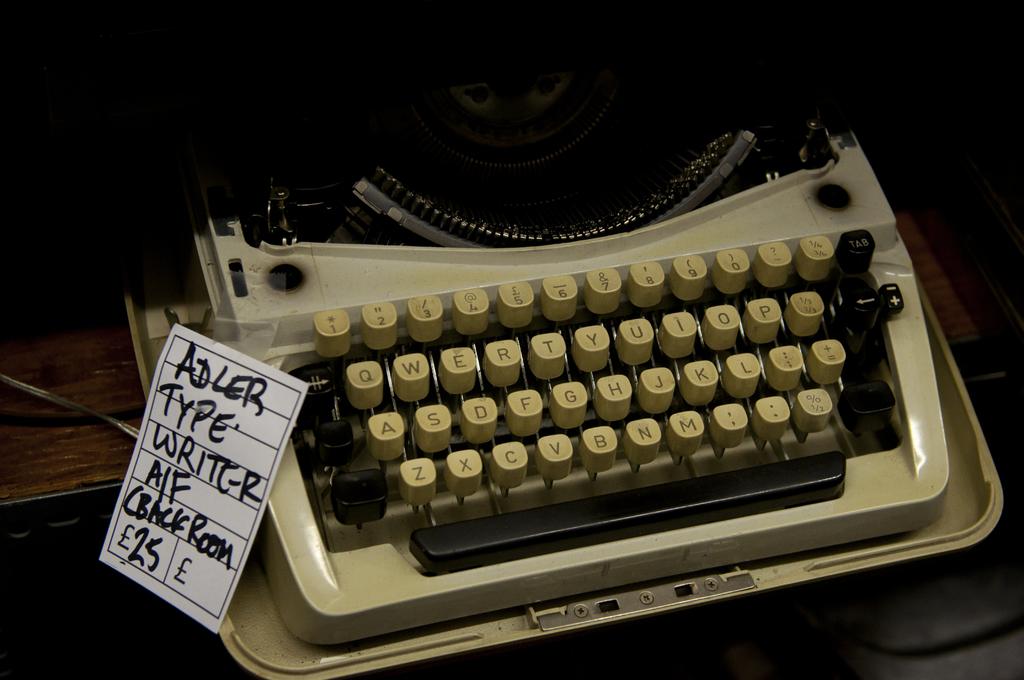What does the note attached to the typewriter say?
Provide a succinct answer. Adler type writer a/f cback room. This a typing machine?
Provide a succinct answer. Yes. 